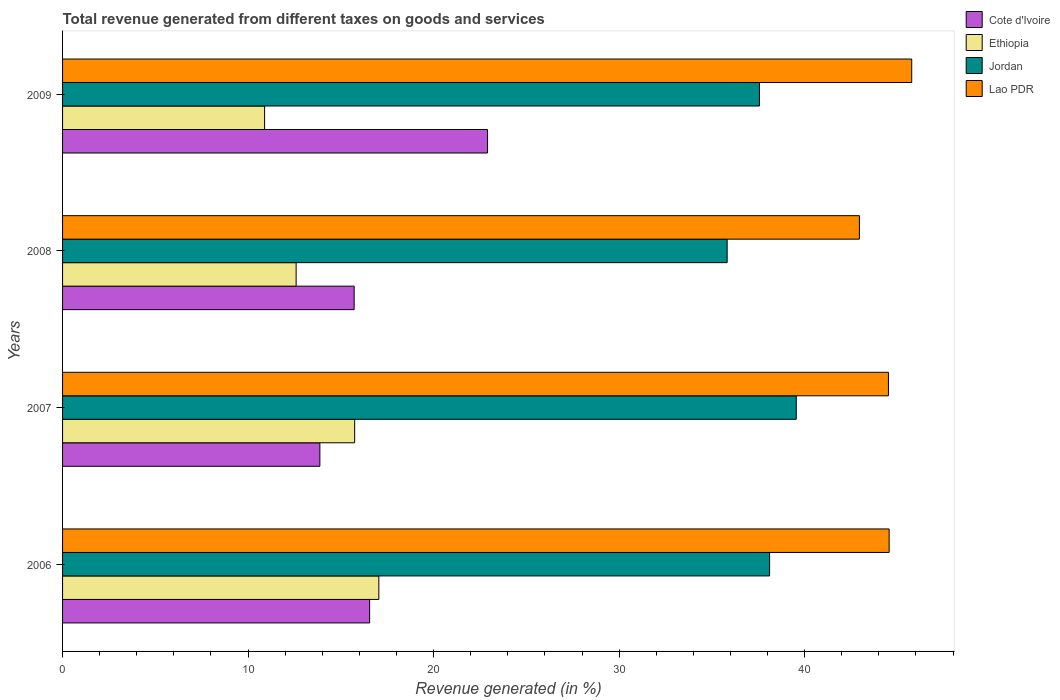How many different coloured bars are there?
Provide a succinct answer. 4. Are the number of bars per tick equal to the number of legend labels?
Ensure brevity in your answer.  Yes. How many bars are there on the 4th tick from the bottom?
Your response must be concise. 4. In how many cases, is the number of bars for a given year not equal to the number of legend labels?
Make the answer very short. 0. What is the total revenue generated in Jordan in 2009?
Provide a short and direct response. 37.56. Across all years, what is the maximum total revenue generated in Jordan?
Your answer should be very brief. 39.55. Across all years, what is the minimum total revenue generated in Lao PDR?
Ensure brevity in your answer.  42.95. In which year was the total revenue generated in Cote d'Ivoire minimum?
Provide a short and direct response. 2007. What is the total total revenue generated in Ethiopia in the graph?
Ensure brevity in your answer.  56.27. What is the difference between the total revenue generated in Jordan in 2007 and that in 2009?
Offer a very short reply. 1.98. What is the difference between the total revenue generated in Ethiopia in 2006 and the total revenue generated in Cote d'Ivoire in 2009?
Your response must be concise. -5.86. What is the average total revenue generated in Cote d'Ivoire per year?
Your answer should be compact. 17.26. In the year 2006, what is the difference between the total revenue generated in Jordan and total revenue generated in Ethiopia?
Keep it short and to the point. 21.06. What is the ratio of the total revenue generated in Jordan in 2006 to that in 2008?
Your answer should be very brief. 1.06. Is the total revenue generated in Ethiopia in 2006 less than that in 2007?
Your answer should be compact. No. What is the difference between the highest and the second highest total revenue generated in Jordan?
Provide a succinct answer. 1.44. What is the difference between the highest and the lowest total revenue generated in Jordan?
Provide a short and direct response. 3.72. Is it the case that in every year, the sum of the total revenue generated in Jordan and total revenue generated in Lao PDR is greater than the sum of total revenue generated in Cote d'Ivoire and total revenue generated in Ethiopia?
Keep it short and to the point. Yes. What does the 1st bar from the top in 2006 represents?
Your answer should be compact. Lao PDR. What does the 4th bar from the bottom in 2007 represents?
Offer a terse response. Lao PDR. Are all the bars in the graph horizontal?
Offer a very short reply. Yes. What is the difference between two consecutive major ticks on the X-axis?
Give a very brief answer. 10. Are the values on the major ticks of X-axis written in scientific E-notation?
Provide a short and direct response. No. Does the graph contain any zero values?
Provide a succinct answer. No. Does the graph contain grids?
Give a very brief answer. No. How are the legend labels stacked?
Give a very brief answer. Vertical. What is the title of the graph?
Offer a terse response. Total revenue generated from different taxes on goods and services. What is the label or title of the X-axis?
Offer a very short reply. Revenue generated (in %). What is the Revenue generated (in %) in Cote d'Ivoire in 2006?
Give a very brief answer. 16.55. What is the Revenue generated (in %) of Ethiopia in 2006?
Provide a succinct answer. 17.05. What is the Revenue generated (in %) in Jordan in 2006?
Keep it short and to the point. 38.11. What is the Revenue generated (in %) of Lao PDR in 2006?
Your answer should be very brief. 44.55. What is the Revenue generated (in %) of Cote d'Ivoire in 2007?
Give a very brief answer. 13.87. What is the Revenue generated (in %) in Ethiopia in 2007?
Your answer should be very brief. 15.74. What is the Revenue generated (in %) of Jordan in 2007?
Ensure brevity in your answer.  39.55. What is the Revenue generated (in %) in Lao PDR in 2007?
Offer a terse response. 44.51. What is the Revenue generated (in %) in Cote d'Ivoire in 2008?
Your response must be concise. 15.72. What is the Revenue generated (in %) of Ethiopia in 2008?
Give a very brief answer. 12.59. What is the Revenue generated (in %) of Jordan in 2008?
Give a very brief answer. 35.82. What is the Revenue generated (in %) of Lao PDR in 2008?
Provide a short and direct response. 42.95. What is the Revenue generated (in %) in Cote d'Ivoire in 2009?
Keep it short and to the point. 22.91. What is the Revenue generated (in %) of Ethiopia in 2009?
Provide a succinct answer. 10.89. What is the Revenue generated (in %) of Jordan in 2009?
Your response must be concise. 37.56. What is the Revenue generated (in %) in Lao PDR in 2009?
Provide a succinct answer. 45.77. Across all years, what is the maximum Revenue generated (in %) of Cote d'Ivoire?
Your answer should be compact. 22.91. Across all years, what is the maximum Revenue generated (in %) in Ethiopia?
Ensure brevity in your answer.  17.05. Across all years, what is the maximum Revenue generated (in %) of Jordan?
Ensure brevity in your answer.  39.55. Across all years, what is the maximum Revenue generated (in %) of Lao PDR?
Provide a succinct answer. 45.77. Across all years, what is the minimum Revenue generated (in %) in Cote d'Ivoire?
Provide a succinct answer. 13.87. Across all years, what is the minimum Revenue generated (in %) of Ethiopia?
Offer a terse response. 10.89. Across all years, what is the minimum Revenue generated (in %) of Jordan?
Give a very brief answer. 35.82. Across all years, what is the minimum Revenue generated (in %) of Lao PDR?
Your answer should be very brief. 42.95. What is the total Revenue generated (in %) of Cote d'Ivoire in the graph?
Offer a very short reply. 69.04. What is the total Revenue generated (in %) in Ethiopia in the graph?
Keep it short and to the point. 56.27. What is the total Revenue generated (in %) in Jordan in the graph?
Give a very brief answer. 151.04. What is the total Revenue generated (in %) in Lao PDR in the graph?
Your answer should be compact. 177.79. What is the difference between the Revenue generated (in %) in Cote d'Ivoire in 2006 and that in 2007?
Your answer should be compact. 2.68. What is the difference between the Revenue generated (in %) of Ethiopia in 2006 and that in 2007?
Offer a very short reply. 1.3. What is the difference between the Revenue generated (in %) of Jordan in 2006 and that in 2007?
Offer a terse response. -1.44. What is the difference between the Revenue generated (in %) in Lao PDR in 2006 and that in 2007?
Your response must be concise. 0.04. What is the difference between the Revenue generated (in %) in Cote d'Ivoire in 2006 and that in 2008?
Your answer should be compact. 0.83. What is the difference between the Revenue generated (in %) of Ethiopia in 2006 and that in 2008?
Make the answer very short. 4.46. What is the difference between the Revenue generated (in %) of Jordan in 2006 and that in 2008?
Provide a short and direct response. 2.29. What is the difference between the Revenue generated (in %) of Lao PDR in 2006 and that in 2008?
Your response must be concise. 1.6. What is the difference between the Revenue generated (in %) in Cote d'Ivoire in 2006 and that in 2009?
Your answer should be compact. -6.36. What is the difference between the Revenue generated (in %) in Ethiopia in 2006 and that in 2009?
Your response must be concise. 6.16. What is the difference between the Revenue generated (in %) in Jordan in 2006 and that in 2009?
Your response must be concise. 0.55. What is the difference between the Revenue generated (in %) in Lao PDR in 2006 and that in 2009?
Provide a succinct answer. -1.22. What is the difference between the Revenue generated (in %) in Cote d'Ivoire in 2007 and that in 2008?
Offer a terse response. -1.85. What is the difference between the Revenue generated (in %) of Ethiopia in 2007 and that in 2008?
Provide a succinct answer. 3.15. What is the difference between the Revenue generated (in %) in Jordan in 2007 and that in 2008?
Provide a succinct answer. 3.72. What is the difference between the Revenue generated (in %) in Lao PDR in 2007 and that in 2008?
Give a very brief answer. 1.56. What is the difference between the Revenue generated (in %) in Cote d'Ivoire in 2007 and that in 2009?
Give a very brief answer. -9.04. What is the difference between the Revenue generated (in %) in Ethiopia in 2007 and that in 2009?
Make the answer very short. 4.85. What is the difference between the Revenue generated (in %) of Jordan in 2007 and that in 2009?
Your answer should be very brief. 1.98. What is the difference between the Revenue generated (in %) of Lao PDR in 2007 and that in 2009?
Give a very brief answer. -1.26. What is the difference between the Revenue generated (in %) in Cote d'Ivoire in 2008 and that in 2009?
Provide a succinct answer. -7.19. What is the difference between the Revenue generated (in %) in Ethiopia in 2008 and that in 2009?
Keep it short and to the point. 1.7. What is the difference between the Revenue generated (in %) of Jordan in 2008 and that in 2009?
Your response must be concise. -1.74. What is the difference between the Revenue generated (in %) of Lao PDR in 2008 and that in 2009?
Ensure brevity in your answer.  -2.82. What is the difference between the Revenue generated (in %) in Cote d'Ivoire in 2006 and the Revenue generated (in %) in Ethiopia in 2007?
Provide a short and direct response. 0.81. What is the difference between the Revenue generated (in %) of Cote d'Ivoire in 2006 and the Revenue generated (in %) of Jordan in 2007?
Provide a short and direct response. -23. What is the difference between the Revenue generated (in %) of Cote d'Ivoire in 2006 and the Revenue generated (in %) of Lao PDR in 2007?
Your answer should be compact. -27.96. What is the difference between the Revenue generated (in %) in Ethiopia in 2006 and the Revenue generated (in %) in Jordan in 2007?
Make the answer very short. -22.5. What is the difference between the Revenue generated (in %) in Ethiopia in 2006 and the Revenue generated (in %) in Lao PDR in 2007?
Your answer should be very brief. -27.47. What is the difference between the Revenue generated (in %) of Jordan in 2006 and the Revenue generated (in %) of Lao PDR in 2007?
Give a very brief answer. -6.41. What is the difference between the Revenue generated (in %) in Cote d'Ivoire in 2006 and the Revenue generated (in %) in Ethiopia in 2008?
Your answer should be compact. 3.96. What is the difference between the Revenue generated (in %) in Cote d'Ivoire in 2006 and the Revenue generated (in %) in Jordan in 2008?
Your answer should be very brief. -19.27. What is the difference between the Revenue generated (in %) in Cote d'Ivoire in 2006 and the Revenue generated (in %) in Lao PDR in 2008?
Provide a short and direct response. -26.4. What is the difference between the Revenue generated (in %) in Ethiopia in 2006 and the Revenue generated (in %) in Jordan in 2008?
Your response must be concise. -18.77. What is the difference between the Revenue generated (in %) of Ethiopia in 2006 and the Revenue generated (in %) of Lao PDR in 2008?
Keep it short and to the point. -25.9. What is the difference between the Revenue generated (in %) of Jordan in 2006 and the Revenue generated (in %) of Lao PDR in 2008?
Give a very brief answer. -4.84. What is the difference between the Revenue generated (in %) of Cote d'Ivoire in 2006 and the Revenue generated (in %) of Ethiopia in 2009?
Your answer should be very brief. 5.66. What is the difference between the Revenue generated (in %) in Cote d'Ivoire in 2006 and the Revenue generated (in %) in Jordan in 2009?
Your answer should be compact. -21.01. What is the difference between the Revenue generated (in %) in Cote d'Ivoire in 2006 and the Revenue generated (in %) in Lao PDR in 2009?
Ensure brevity in your answer.  -29.22. What is the difference between the Revenue generated (in %) in Ethiopia in 2006 and the Revenue generated (in %) in Jordan in 2009?
Keep it short and to the point. -20.52. What is the difference between the Revenue generated (in %) in Ethiopia in 2006 and the Revenue generated (in %) in Lao PDR in 2009?
Provide a short and direct response. -28.72. What is the difference between the Revenue generated (in %) in Jordan in 2006 and the Revenue generated (in %) in Lao PDR in 2009?
Give a very brief answer. -7.66. What is the difference between the Revenue generated (in %) in Cote d'Ivoire in 2007 and the Revenue generated (in %) in Ethiopia in 2008?
Your answer should be compact. 1.28. What is the difference between the Revenue generated (in %) of Cote d'Ivoire in 2007 and the Revenue generated (in %) of Jordan in 2008?
Your response must be concise. -21.95. What is the difference between the Revenue generated (in %) in Cote d'Ivoire in 2007 and the Revenue generated (in %) in Lao PDR in 2008?
Give a very brief answer. -29.08. What is the difference between the Revenue generated (in %) in Ethiopia in 2007 and the Revenue generated (in %) in Jordan in 2008?
Make the answer very short. -20.08. What is the difference between the Revenue generated (in %) in Ethiopia in 2007 and the Revenue generated (in %) in Lao PDR in 2008?
Offer a very short reply. -27.21. What is the difference between the Revenue generated (in %) of Jordan in 2007 and the Revenue generated (in %) of Lao PDR in 2008?
Your answer should be very brief. -3.4. What is the difference between the Revenue generated (in %) in Cote d'Ivoire in 2007 and the Revenue generated (in %) in Ethiopia in 2009?
Make the answer very short. 2.98. What is the difference between the Revenue generated (in %) in Cote d'Ivoire in 2007 and the Revenue generated (in %) in Jordan in 2009?
Provide a succinct answer. -23.69. What is the difference between the Revenue generated (in %) of Cote d'Ivoire in 2007 and the Revenue generated (in %) of Lao PDR in 2009?
Offer a very short reply. -31.9. What is the difference between the Revenue generated (in %) of Ethiopia in 2007 and the Revenue generated (in %) of Jordan in 2009?
Provide a short and direct response. -21.82. What is the difference between the Revenue generated (in %) of Ethiopia in 2007 and the Revenue generated (in %) of Lao PDR in 2009?
Ensure brevity in your answer.  -30.03. What is the difference between the Revenue generated (in %) of Jordan in 2007 and the Revenue generated (in %) of Lao PDR in 2009?
Provide a succinct answer. -6.22. What is the difference between the Revenue generated (in %) in Cote d'Ivoire in 2008 and the Revenue generated (in %) in Ethiopia in 2009?
Your response must be concise. 4.83. What is the difference between the Revenue generated (in %) in Cote d'Ivoire in 2008 and the Revenue generated (in %) in Jordan in 2009?
Your answer should be compact. -21.85. What is the difference between the Revenue generated (in %) in Cote d'Ivoire in 2008 and the Revenue generated (in %) in Lao PDR in 2009?
Offer a terse response. -30.05. What is the difference between the Revenue generated (in %) in Ethiopia in 2008 and the Revenue generated (in %) in Jordan in 2009?
Your response must be concise. -24.97. What is the difference between the Revenue generated (in %) of Ethiopia in 2008 and the Revenue generated (in %) of Lao PDR in 2009?
Ensure brevity in your answer.  -33.18. What is the difference between the Revenue generated (in %) of Jordan in 2008 and the Revenue generated (in %) of Lao PDR in 2009?
Your response must be concise. -9.95. What is the average Revenue generated (in %) of Cote d'Ivoire per year?
Provide a succinct answer. 17.26. What is the average Revenue generated (in %) of Ethiopia per year?
Provide a short and direct response. 14.07. What is the average Revenue generated (in %) of Jordan per year?
Your answer should be compact. 37.76. What is the average Revenue generated (in %) in Lao PDR per year?
Your answer should be very brief. 44.45. In the year 2006, what is the difference between the Revenue generated (in %) of Cote d'Ivoire and Revenue generated (in %) of Ethiopia?
Give a very brief answer. -0.5. In the year 2006, what is the difference between the Revenue generated (in %) of Cote d'Ivoire and Revenue generated (in %) of Jordan?
Your response must be concise. -21.56. In the year 2006, what is the difference between the Revenue generated (in %) in Cote d'Ivoire and Revenue generated (in %) in Lao PDR?
Offer a terse response. -28. In the year 2006, what is the difference between the Revenue generated (in %) in Ethiopia and Revenue generated (in %) in Jordan?
Offer a terse response. -21.06. In the year 2006, what is the difference between the Revenue generated (in %) in Ethiopia and Revenue generated (in %) in Lao PDR?
Keep it short and to the point. -27.51. In the year 2006, what is the difference between the Revenue generated (in %) in Jordan and Revenue generated (in %) in Lao PDR?
Give a very brief answer. -6.44. In the year 2007, what is the difference between the Revenue generated (in %) in Cote d'Ivoire and Revenue generated (in %) in Ethiopia?
Your answer should be very brief. -1.87. In the year 2007, what is the difference between the Revenue generated (in %) in Cote d'Ivoire and Revenue generated (in %) in Jordan?
Your response must be concise. -25.68. In the year 2007, what is the difference between the Revenue generated (in %) of Cote d'Ivoire and Revenue generated (in %) of Lao PDR?
Give a very brief answer. -30.65. In the year 2007, what is the difference between the Revenue generated (in %) in Ethiopia and Revenue generated (in %) in Jordan?
Make the answer very short. -23.8. In the year 2007, what is the difference between the Revenue generated (in %) of Ethiopia and Revenue generated (in %) of Lao PDR?
Ensure brevity in your answer.  -28.77. In the year 2007, what is the difference between the Revenue generated (in %) in Jordan and Revenue generated (in %) in Lao PDR?
Provide a succinct answer. -4.97. In the year 2008, what is the difference between the Revenue generated (in %) in Cote d'Ivoire and Revenue generated (in %) in Ethiopia?
Keep it short and to the point. 3.13. In the year 2008, what is the difference between the Revenue generated (in %) in Cote d'Ivoire and Revenue generated (in %) in Jordan?
Your response must be concise. -20.11. In the year 2008, what is the difference between the Revenue generated (in %) of Cote d'Ivoire and Revenue generated (in %) of Lao PDR?
Offer a very short reply. -27.23. In the year 2008, what is the difference between the Revenue generated (in %) in Ethiopia and Revenue generated (in %) in Jordan?
Provide a succinct answer. -23.23. In the year 2008, what is the difference between the Revenue generated (in %) of Ethiopia and Revenue generated (in %) of Lao PDR?
Your answer should be very brief. -30.36. In the year 2008, what is the difference between the Revenue generated (in %) of Jordan and Revenue generated (in %) of Lao PDR?
Provide a short and direct response. -7.13. In the year 2009, what is the difference between the Revenue generated (in %) of Cote d'Ivoire and Revenue generated (in %) of Ethiopia?
Keep it short and to the point. 12.02. In the year 2009, what is the difference between the Revenue generated (in %) of Cote d'Ivoire and Revenue generated (in %) of Jordan?
Make the answer very short. -14.66. In the year 2009, what is the difference between the Revenue generated (in %) of Cote d'Ivoire and Revenue generated (in %) of Lao PDR?
Give a very brief answer. -22.86. In the year 2009, what is the difference between the Revenue generated (in %) in Ethiopia and Revenue generated (in %) in Jordan?
Make the answer very short. -26.67. In the year 2009, what is the difference between the Revenue generated (in %) of Ethiopia and Revenue generated (in %) of Lao PDR?
Give a very brief answer. -34.88. In the year 2009, what is the difference between the Revenue generated (in %) in Jordan and Revenue generated (in %) in Lao PDR?
Offer a very short reply. -8.21. What is the ratio of the Revenue generated (in %) in Cote d'Ivoire in 2006 to that in 2007?
Offer a terse response. 1.19. What is the ratio of the Revenue generated (in %) of Ethiopia in 2006 to that in 2007?
Provide a succinct answer. 1.08. What is the ratio of the Revenue generated (in %) of Jordan in 2006 to that in 2007?
Provide a short and direct response. 0.96. What is the ratio of the Revenue generated (in %) in Lao PDR in 2006 to that in 2007?
Keep it short and to the point. 1. What is the ratio of the Revenue generated (in %) in Cote d'Ivoire in 2006 to that in 2008?
Ensure brevity in your answer.  1.05. What is the ratio of the Revenue generated (in %) of Ethiopia in 2006 to that in 2008?
Provide a short and direct response. 1.35. What is the ratio of the Revenue generated (in %) of Jordan in 2006 to that in 2008?
Offer a terse response. 1.06. What is the ratio of the Revenue generated (in %) in Lao PDR in 2006 to that in 2008?
Your answer should be very brief. 1.04. What is the ratio of the Revenue generated (in %) in Cote d'Ivoire in 2006 to that in 2009?
Provide a succinct answer. 0.72. What is the ratio of the Revenue generated (in %) in Ethiopia in 2006 to that in 2009?
Give a very brief answer. 1.57. What is the ratio of the Revenue generated (in %) of Jordan in 2006 to that in 2009?
Your response must be concise. 1.01. What is the ratio of the Revenue generated (in %) in Lao PDR in 2006 to that in 2009?
Keep it short and to the point. 0.97. What is the ratio of the Revenue generated (in %) of Cote d'Ivoire in 2007 to that in 2008?
Keep it short and to the point. 0.88. What is the ratio of the Revenue generated (in %) of Ethiopia in 2007 to that in 2008?
Provide a short and direct response. 1.25. What is the ratio of the Revenue generated (in %) in Jordan in 2007 to that in 2008?
Offer a very short reply. 1.1. What is the ratio of the Revenue generated (in %) in Lao PDR in 2007 to that in 2008?
Provide a succinct answer. 1.04. What is the ratio of the Revenue generated (in %) of Cote d'Ivoire in 2007 to that in 2009?
Your answer should be compact. 0.61. What is the ratio of the Revenue generated (in %) of Ethiopia in 2007 to that in 2009?
Offer a terse response. 1.45. What is the ratio of the Revenue generated (in %) in Jordan in 2007 to that in 2009?
Keep it short and to the point. 1.05. What is the ratio of the Revenue generated (in %) of Lao PDR in 2007 to that in 2009?
Keep it short and to the point. 0.97. What is the ratio of the Revenue generated (in %) of Cote d'Ivoire in 2008 to that in 2009?
Ensure brevity in your answer.  0.69. What is the ratio of the Revenue generated (in %) in Ethiopia in 2008 to that in 2009?
Keep it short and to the point. 1.16. What is the ratio of the Revenue generated (in %) in Jordan in 2008 to that in 2009?
Offer a very short reply. 0.95. What is the ratio of the Revenue generated (in %) in Lao PDR in 2008 to that in 2009?
Your answer should be very brief. 0.94. What is the difference between the highest and the second highest Revenue generated (in %) of Cote d'Ivoire?
Make the answer very short. 6.36. What is the difference between the highest and the second highest Revenue generated (in %) in Ethiopia?
Your answer should be compact. 1.3. What is the difference between the highest and the second highest Revenue generated (in %) of Jordan?
Ensure brevity in your answer.  1.44. What is the difference between the highest and the second highest Revenue generated (in %) of Lao PDR?
Ensure brevity in your answer.  1.22. What is the difference between the highest and the lowest Revenue generated (in %) in Cote d'Ivoire?
Offer a terse response. 9.04. What is the difference between the highest and the lowest Revenue generated (in %) in Ethiopia?
Provide a succinct answer. 6.16. What is the difference between the highest and the lowest Revenue generated (in %) of Jordan?
Make the answer very short. 3.72. What is the difference between the highest and the lowest Revenue generated (in %) of Lao PDR?
Keep it short and to the point. 2.82. 